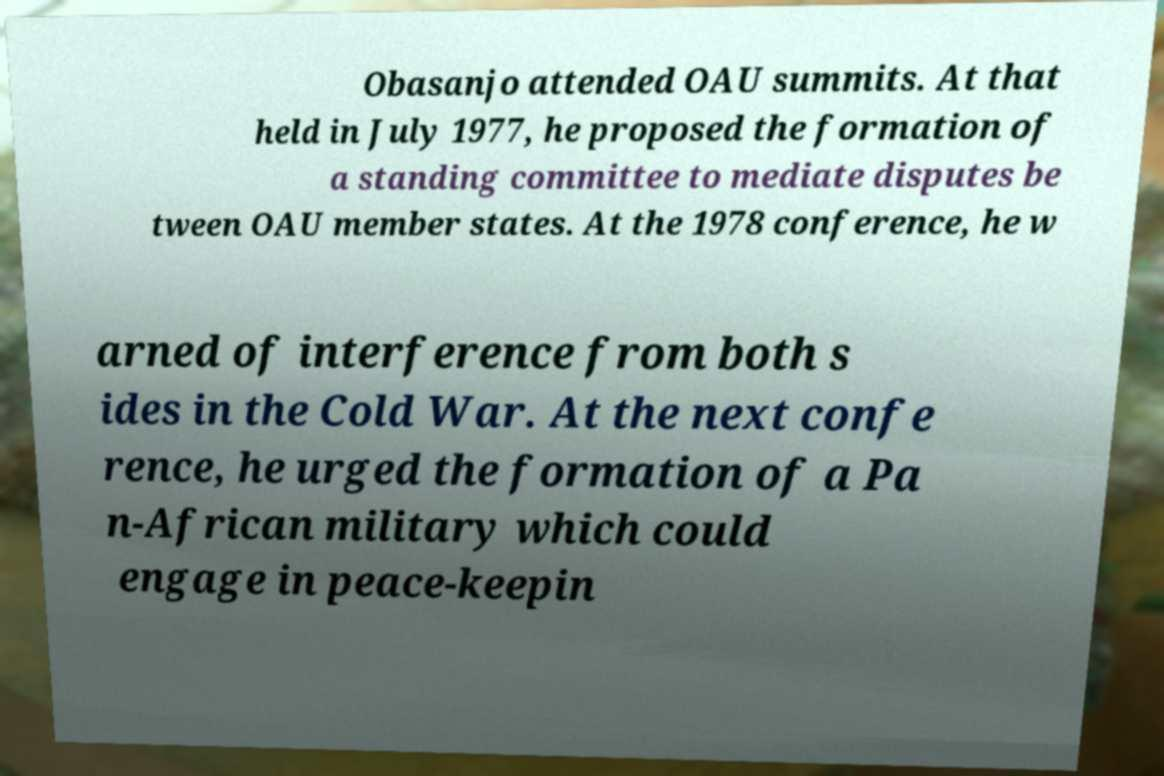Can you accurately transcribe the text from the provided image for me? Obasanjo attended OAU summits. At that held in July 1977, he proposed the formation of a standing committee to mediate disputes be tween OAU member states. At the 1978 conference, he w arned of interference from both s ides in the Cold War. At the next confe rence, he urged the formation of a Pa n-African military which could engage in peace-keepin 